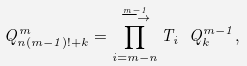Convert formula to latex. <formula><loc_0><loc_0><loc_500><loc_500>Q ^ { m } _ { n ( m - 1 ) ! + k } = \prod _ { i = m - n } ^ { \stackrel { m - 1 } { \longrightarrow } } T _ { i } \ Q _ { k } ^ { m - 1 } ,</formula> 